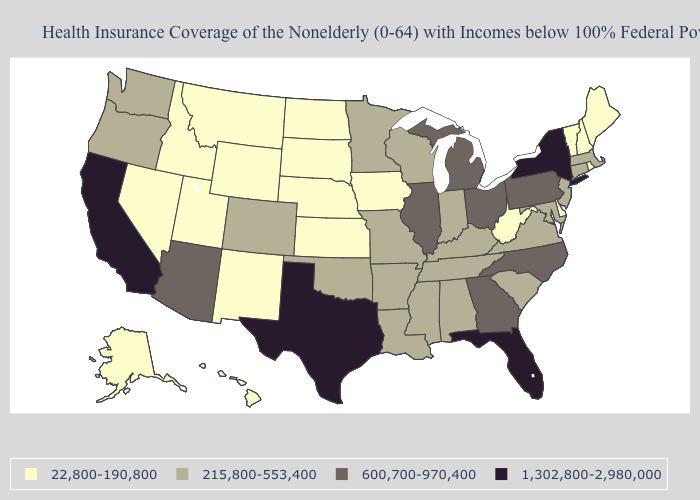What is the highest value in states that border Alabama?
Keep it brief. 1,302,800-2,980,000. What is the value of Arkansas?
Concise answer only. 215,800-553,400. Which states have the lowest value in the West?
Keep it brief. Alaska, Hawaii, Idaho, Montana, Nevada, New Mexico, Utah, Wyoming. What is the lowest value in the USA?
Write a very short answer. 22,800-190,800. Name the states that have a value in the range 600,700-970,400?
Be succinct. Arizona, Georgia, Illinois, Michigan, North Carolina, Ohio, Pennsylvania. Name the states that have a value in the range 600,700-970,400?
Be succinct. Arizona, Georgia, Illinois, Michigan, North Carolina, Ohio, Pennsylvania. What is the value of Mississippi?
Quick response, please. 215,800-553,400. What is the lowest value in the USA?
Concise answer only. 22,800-190,800. Is the legend a continuous bar?
Write a very short answer. No. What is the value of Vermont?
Give a very brief answer. 22,800-190,800. Among the states that border South Dakota , which have the lowest value?
Be succinct. Iowa, Montana, Nebraska, North Dakota, Wyoming. What is the value of Kentucky?
Keep it brief. 215,800-553,400. Among the states that border Colorado , which have the lowest value?
Concise answer only. Kansas, Nebraska, New Mexico, Utah, Wyoming. How many symbols are there in the legend?
Concise answer only. 4. Does the map have missing data?
Quick response, please. No. 